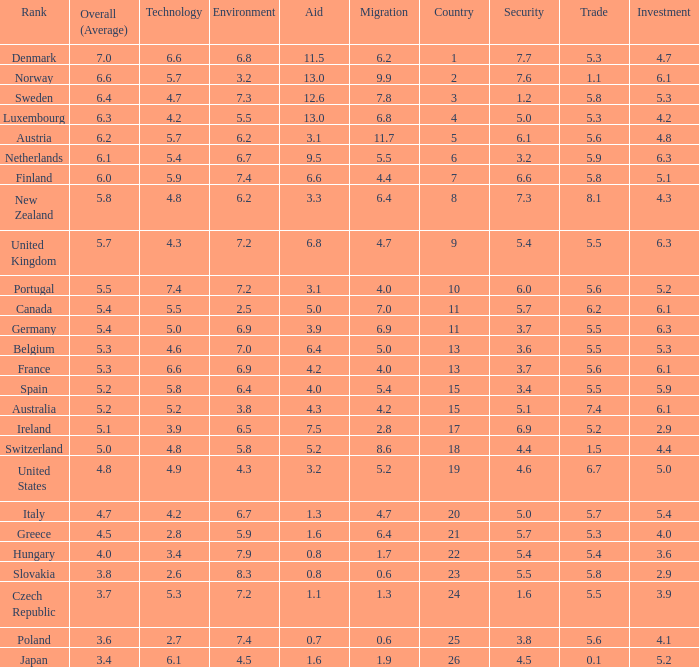What country has a 5.5 mark for security? Slovakia. 